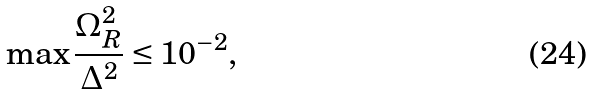Convert formula to latex. <formula><loc_0><loc_0><loc_500><loc_500>\max \frac { \Omega _ { R } ^ { 2 } } { \Delta ^ { 2 } } \leq 1 0 ^ { - 2 } ,</formula> 